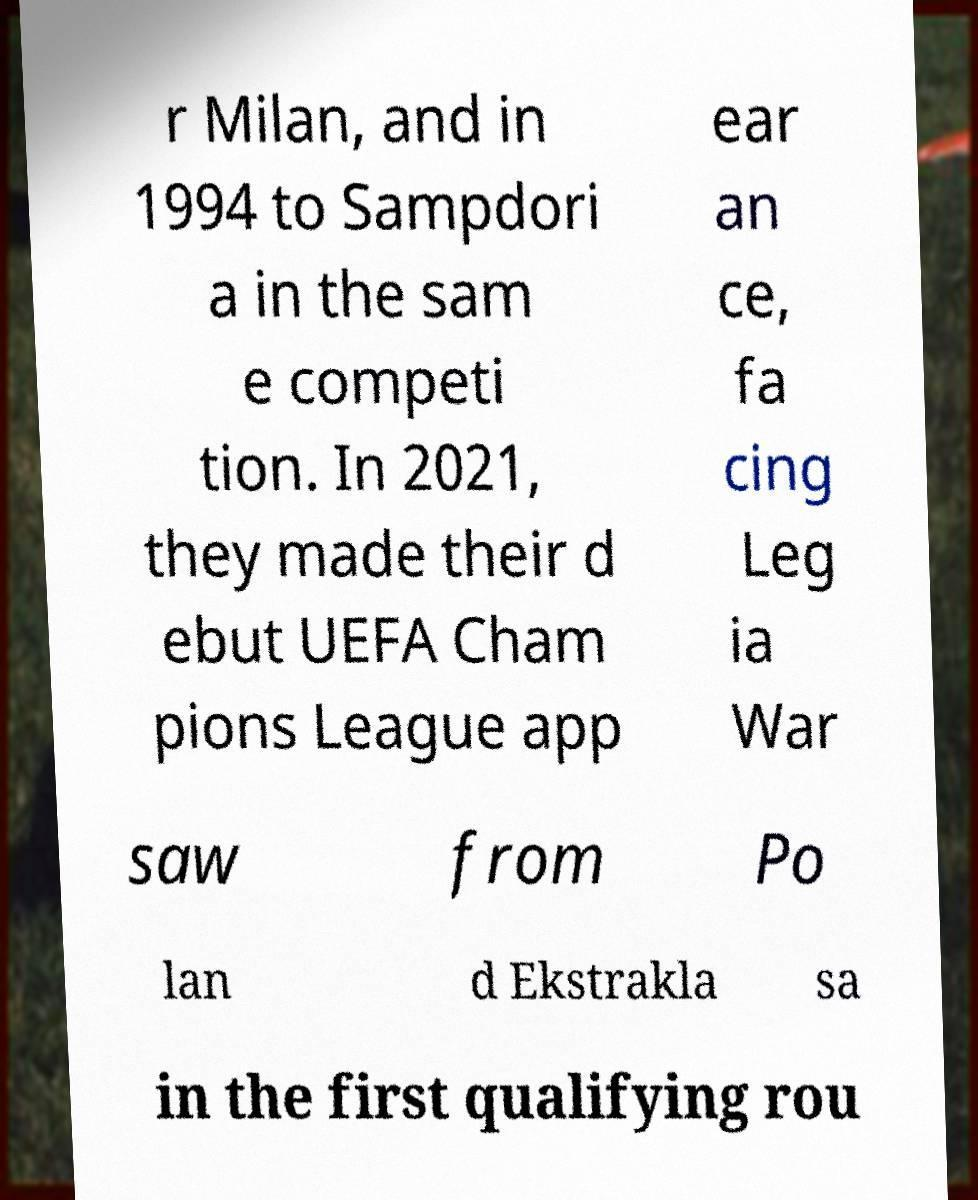For documentation purposes, I need the text within this image transcribed. Could you provide that? r Milan, and in 1994 to Sampdori a in the sam e competi tion. In 2021, they made their d ebut UEFA Cham pions League app ear an ce, fa cing Leg ia War saw from Po lan d Ekstrakla sa in the first qualifying rou 